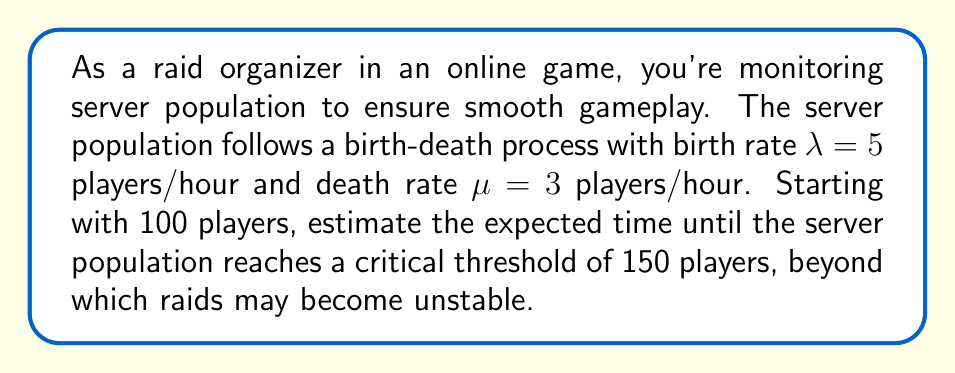Solve this math problem. Let's approach this step-by-step using the properties of birth-death processes:

1) In a birth-death process, the expected time to reach a state n from an initial state i is given by:

   $$E[T_{i,n}] = \frac{1}{\lambda - \mu} \sum_{k=i}^{n-1} \frac{1}{\pi_k}$$

   where $\pi_k$ is the stationary distribution at state k.

2) For a birth-death process, $\pi_k$ is proportional to $(\lambda/\mu)^k$. Therefore:

   $$\pi_k \propto (\lambda/\mu)^k = (5/3)^k$$

3) We need to calculate:

   $$E[T_{100,150}] = \frac{1}{5 - 3} \sum_{k=100}^{149} \frac{1}{(5/3)^k}$$

4) Simplifying:

   $$E[T_{100,150}] = \frac{1}{2} \sum_{k=100}^{149} (\frac{3}{5})^k$$

5) This is a geometric series with 50 terms. The sum of a geometric series is given by:

   $$S_n = \frac{a(1-r^n)}{1-r}$$

   where a is the first term, r is the common ratio, and n is the number of terms.

6) In our case:
   $a = (\frac{3}{5})^{100}$
   $r = \frac{3}{5}$
   $n = 50$

7) Plugging into the formula:

   $$E[T_{100,150}] = \frac{1}{2} \cdot \frac{(\frac{3}{5})^{100}(1-(\frac{3}{5})^{50})}{1-\frac{3}{5}}$$

8) Simplifying:

   $$E[T_{100,150}] = \frac{5}{4} \cdot (\frac{3}{5})^{100}(1-(\frac{3}{5})^{50})$$

9) Calculating this value (you may need a calculator):

   $$E[T_{100,150}] \approx 2.18 \text{ hours}$$
Answer: 2.18 hours 